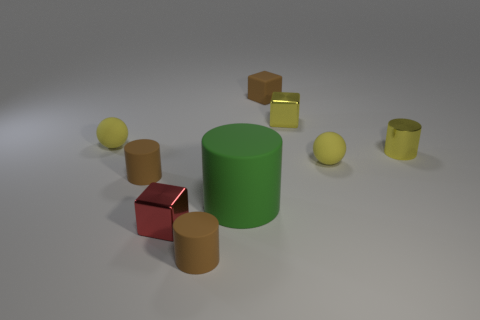There is a tiny block that is the same color as the metal cylinder; what is it made of?
Make the answer very short. Metal. What is the color of the other metal cube that is the same size as the red metallic cube?
Offer a terse response. Yellow. Do the yellow cylinder and the red object have the same size?
Ensure brevity in your answer.  Yes. What size is the brown thing that is behind the red metal block and left of the small brown cube?
Your response must be concise. Small. How many rubber things are small brown cubes or yellow objects?
Give a very brief answer. 3. Is the number of tiny cubes in front of the brown cube greater than the number of large brown blocks?
Offer a terse response. Yes. What is the material of the small brown object that is behind the yellow metal cube?
Your answer should be very brief. Rubber. How many cylinders have the same material as the tiny red object?
Make the answer very short. 1. What is the shape of the rubber object that is both in front of the small yellow metal cylinder and to the left of the tiny red object?
Ensure brevity in your answer.  Cylinder. How many objects are tiny metallic objects on the right side of the brown cube or blocks that are to the right of the small rubber block?
Your answer should be very brief. 2. 